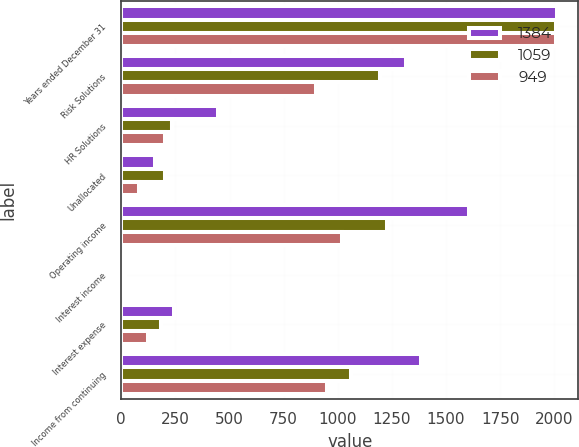Convert chart. <chart><loc_0><loc_0><loc_500><loc_500><stacked_bar_chart><ecel><fcel>Years ended December 31<fcel>Risk Solutions<fcel>HR Solutions<fcel>Unallocated<fcel>Operating income<fcel>Interest income<fcel>Interest expense<fcel>Income from continuing<nl><fcel>1384<fcel>2011<fcel>1314<fcel>448<fcel>156<fcel>1606<fcel>18<fcel>245<fcel>1384<nl><fcel>1059<fcel>2010<fcel>1194<fcel>234<fcel>202<fcel>1226<fcel>15<fcel>182<fcel>1059<nl><fcel>949<fcel>2009<fcel>900<fcel>203<fcel>82<fcel>1021<fcel>16<fcel>122<fcel>949<nl></chart> 